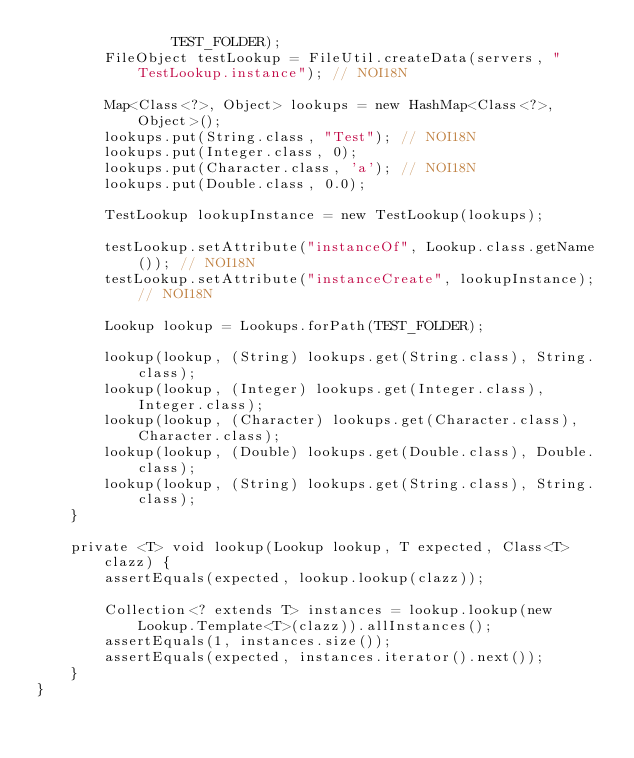Convert code to text. <code><loc_0><loc_0><loc_500><loc_500><_Java_>                TEST_FOLDER);
        FileObject testLookup = FileUtil.createData(servers, "TestLookup.instance"); // NOI18N

        Map<Class<?>, Object> lookups = new HashMap<Class<?>, Object>();
        lookups.put(String.class, "Test"); // NOI18N
        lookups.put(Integer.class, 0);
        lookups.put(Character.class, 'a'); // NOI18N
        lookups.put(Double.class, 0.0);

        TestLookup lookupInstance = new TestLookup(lookups);

        testLookup.setAttribute("instanceOf", Lookup.class.getName()); // NOI18N
        testLookup.setAttribute("instanceCreate", lookupInstance); // NOI18N

        Lookup lookup = Lookups.forPath(TEST_FOLDER);

        lookup(lookup, (String) lookups.get(String.class), String.class);
        lookup(lookup, (Integer) lookups.get(Integer.class), Integer.class);
        lookup(lookup, (Character) lookups.get(Character.class), Character.class);
        lookup(lookup, (Double) lookups.get(Double.class), Double.class);
        lookup(lookup, (String) lookups.get(String.class), String.class);
    }

    private <T> void lookup(Lookup lookup, T expected, Class<T> clazz) {
        assertEquals(expected, lookup.lookup(clazz));

        Collection<? extends T> instances = lookup.lookup(new Lookup.Template<T>(clazz)).allInstances();
        assertEquals(1, instances.size());
        assertEquals(expected, instances.iterator().next());
    }
}
</code> 